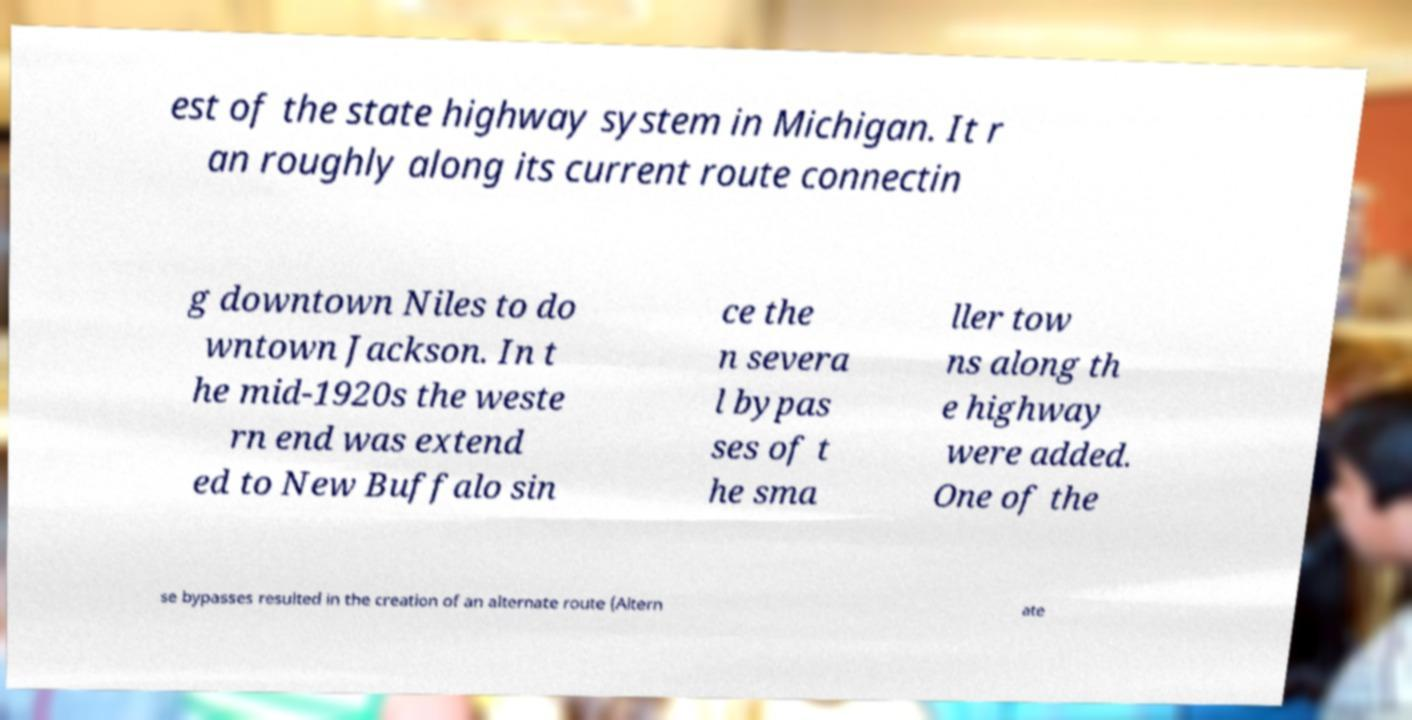Can you read and provide the text displayed in the image?This photo seems to have some interesting text. Can you extract and type it out for me? est of the state highway system in Michigan. It r an roughly along its current route connectin g downtown Niles to do wntown Jackson. In t he mid-1920s the weste rn end was extend ed to New Buffalo sin ce the n severa l bypas ses of t he sma ller tow ns along th e highway were added. One of the se bypasses resulted in the creation of an alternate route (Altern ate 